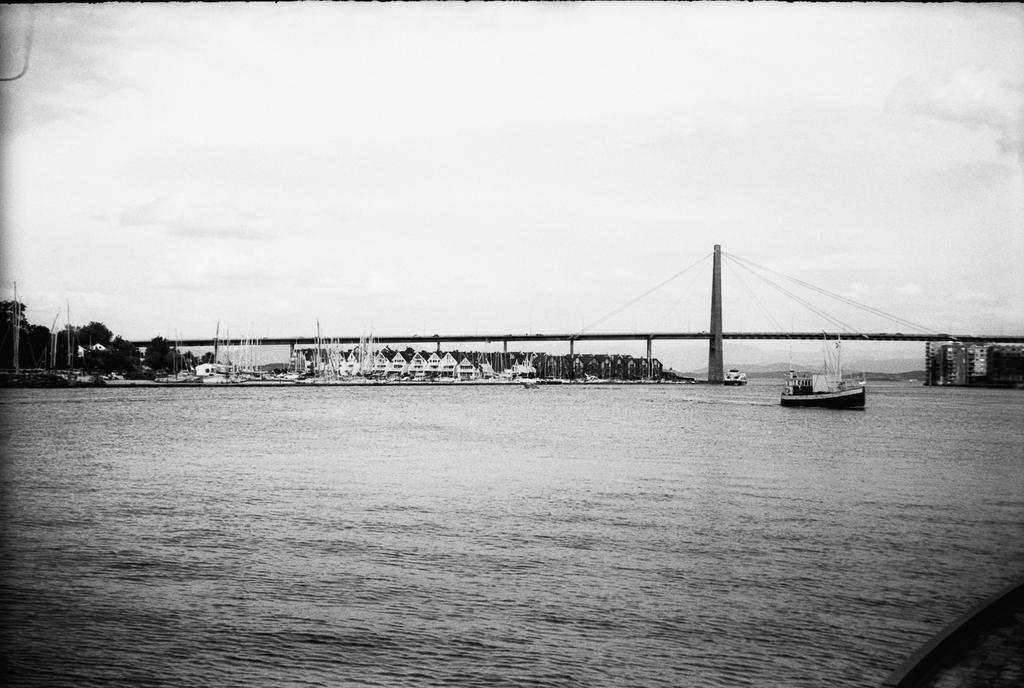What is the color scheme of the image? The image is black and white. What type of structure can be seen in the image? There is a bridge in the image. What architectural elements are present in the image? There are pillars and poles in the image. What type of vegetation is visible in the image? There are trees in the image. What type of man-made structures are present in the image? There are buildings in the image. What mode of transportation is visible in the image? There is a boat in the image. What natural elements are present in the image? There is water at the bottom of the image and sky at the top of the image. What type of glove is the secretary wearing in the image? There is no glove or secretary present in the image. What type of locket is hanging from the boat in the image? There is no locket present in the image, and the boat is not wearing anything. 